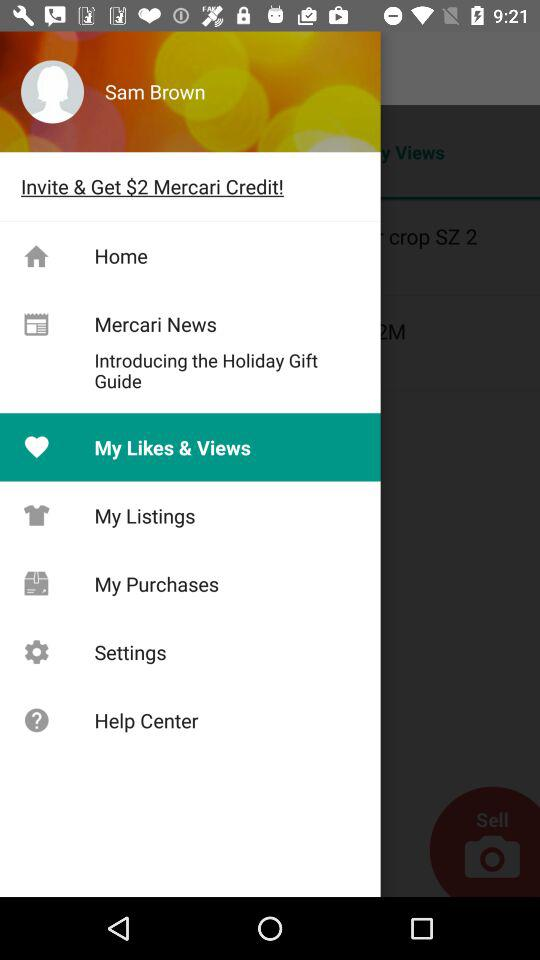How much is the amount after the invitation?
When the provided information is insufficient, respond with <no answer>. <no answer> 